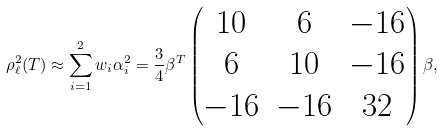<formula> <loc_0><loc_0><loc_500><loc_500>\rho _ { \ell } ^ { 2 } ( T ) \approx \sum _ { i = 1 } ^ { 2 } w _ { i } \alpha _ { i } ^ { 2 } = \frac { 3 } { 4 } \beta ^ { T } \begin{pmatrix} 1 0 & 6 & - 1 6 \\ 6 & 1 0 & - 1 6 \\ - 1 6 & - 1 6 & 3 2 \end{pmatrix} \beta ,</formula> 